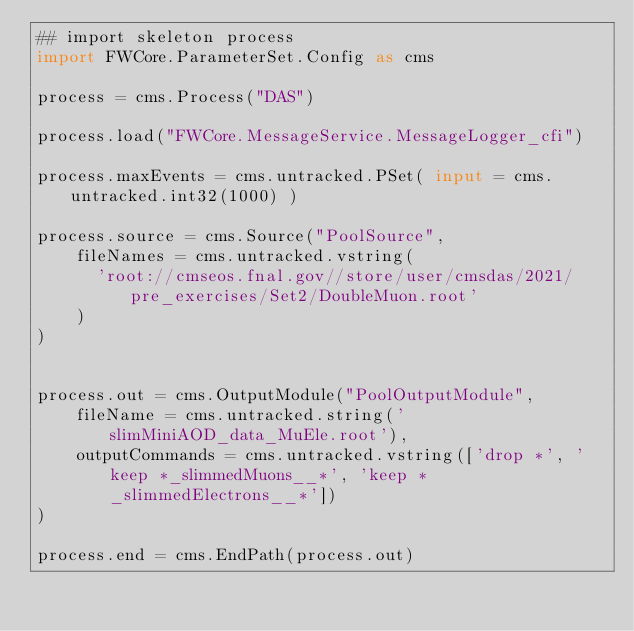Convert code to text. <code><loc_0><loc_0><loc_500><loc_500><_Python_>## import skeleton process
import FWCore.ParameterSet.Config as cms

process = cms.Process("DAS")

process.load("FWCore.MessageService.MessageLogger_cfi")

process.maxEvents = cms.untracked.PSet( input = cms.untracked.int32(1000) )

process.source = cms.Source("PoolSource",
    fileNames = cms.untracked.vstring(
      'root://cmseos.fnal.gov//store/user/cmsdas/2021/pre_exercises/Set2/DoubleMuon.root'
    )
)


process.out = cms.OutputModule("PoolOutputModule",
    fileName = cms.untracked.string('slimMiniAOD_data_MuEle.root'),
    outputCommands = cms.untracked.vstring(['drop *', 'keep *_slimmedMuons__*', 'keep *_slimmedElectrons__*'])
)

process.end = cms.EndPath(process.out)
</code> 